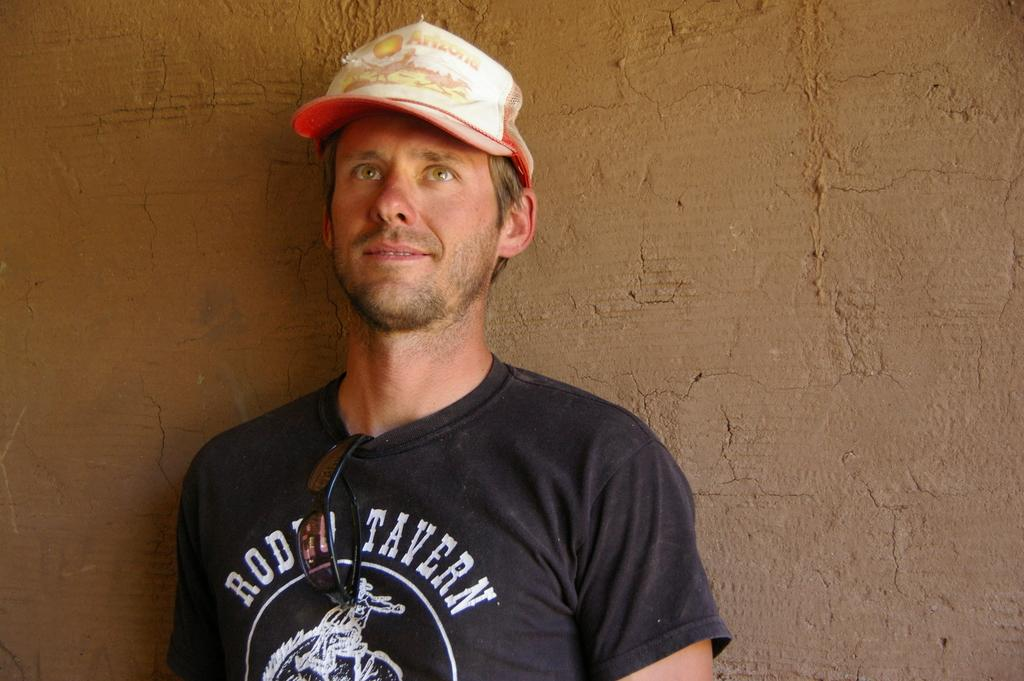<image>
Offer a succinct explanation of the picture presented. a shirt with Rodeo Tavern written on it 